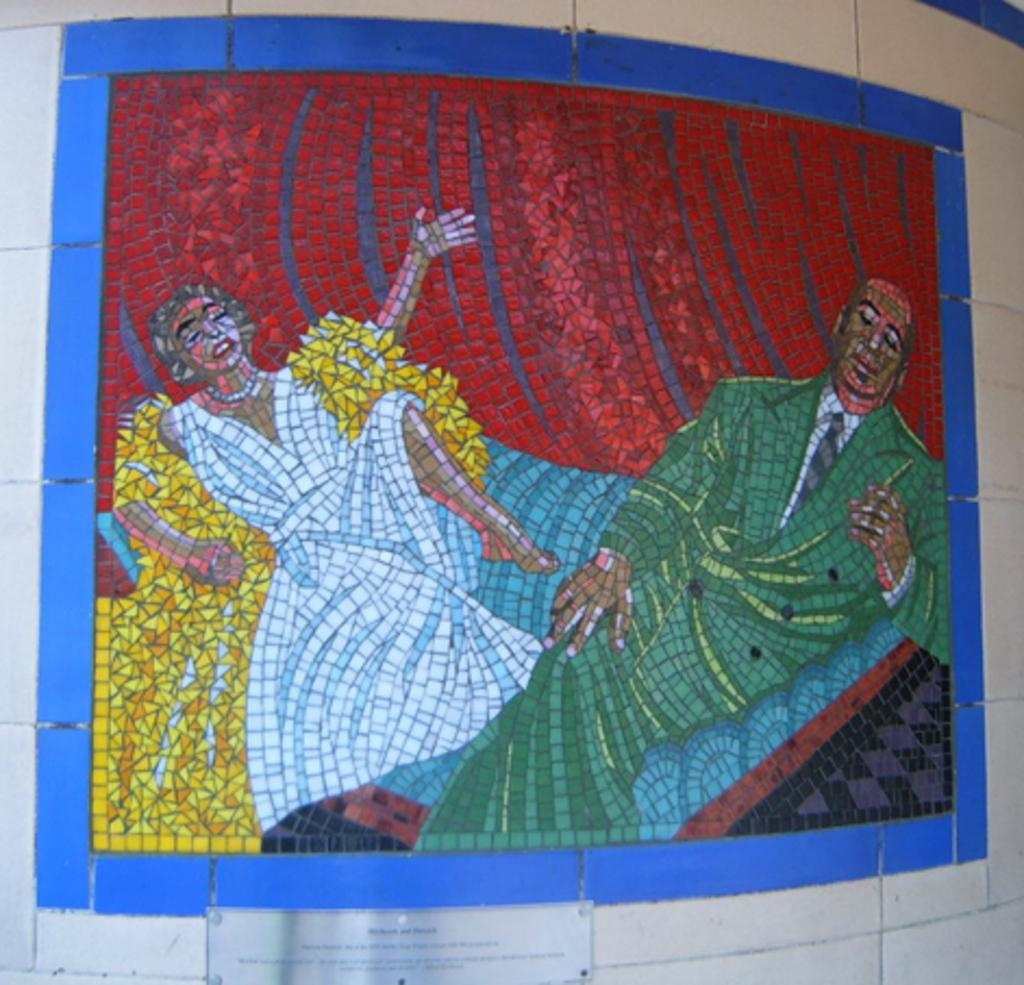What is the main subject of the image? The image contains a painting. What is happening in the painting? The painting depicts two persons. Can you describe the clothing of one of the persons in the painting? One woman in the painting is wearing a white dress. What color is the coat worn by one of the persons in the painting? One person in the painting is wearing a green coat. How many fish can be seen swimming in the painting? There are no fish present in the painting; it depicts two persons. Is there a bottle visible in the painting? There is no bottle present in the painting; it only depicts two persons. 